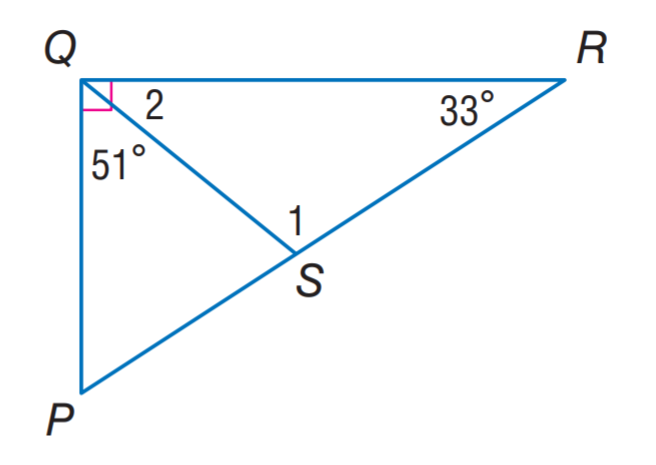Question: Find m \angle 2.
Choices:
A. 33
B. 39
C. 51
D. 108
Answer with the letter. Answer: B 